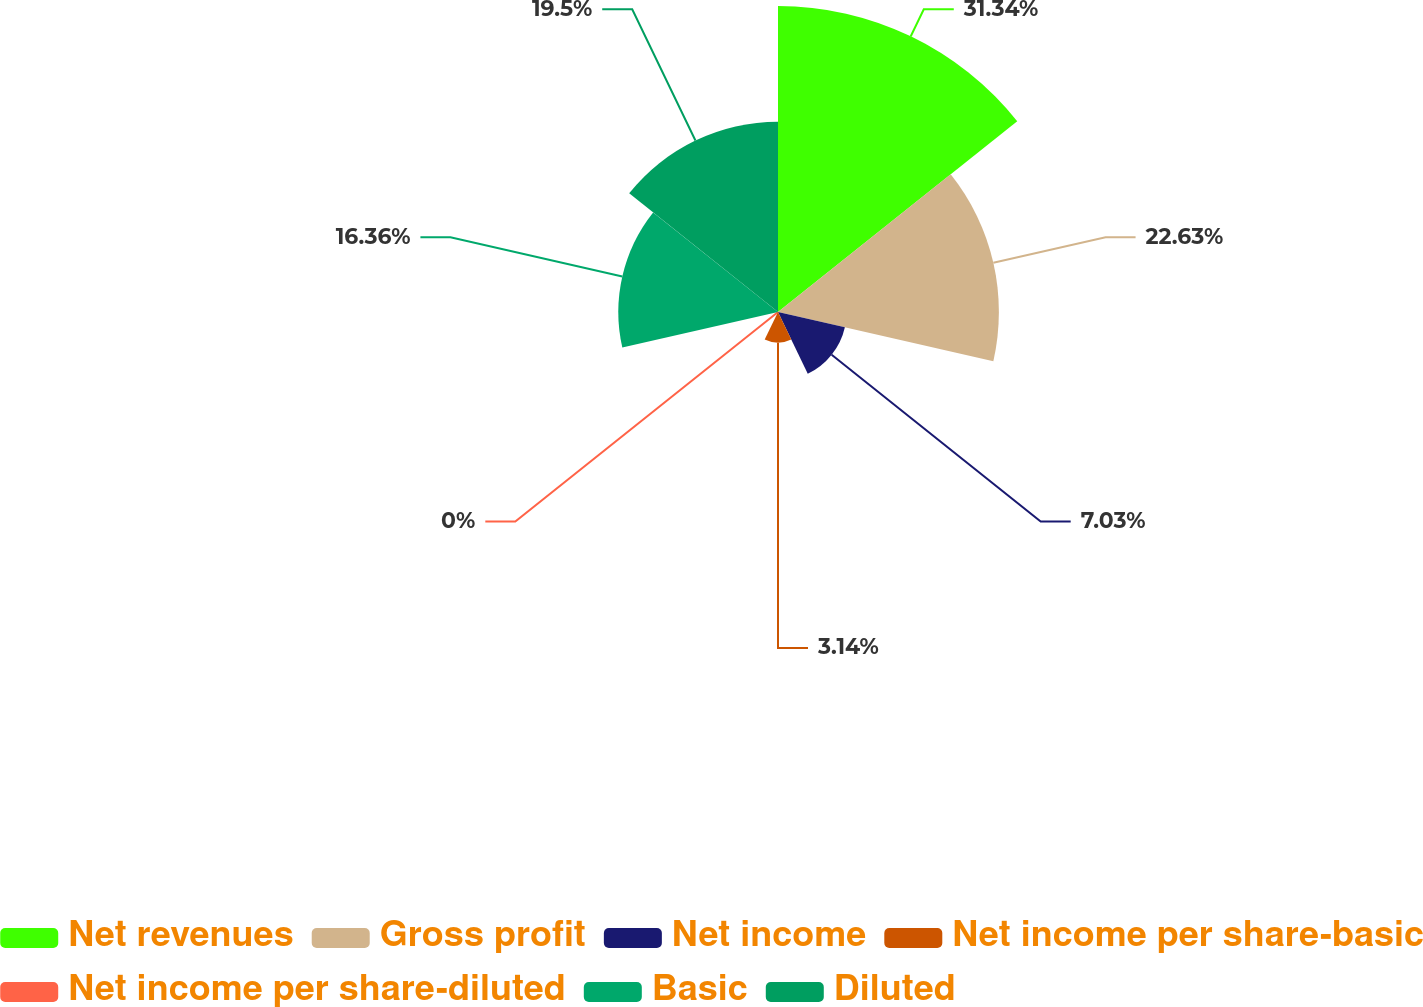<chart> <loc_0><loc_0><loc_500><loc_500><pie_chart><fcel>Net revenues<fcel>Gross profit<fcel>Net income<fcel>Net income per share-basic<fcel>Net income per share-diluted<fcel>Basic<fcel>Diluted<nl><fcel>31.35%<fcel>22.63%<fcel>7.03%<fcel>3.14%<fcel>0.0%<fcel>16.36%<fcel>19.5%<nl></chart> 